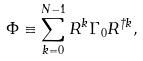<formula> <loc_0><loc_0><loc_500><loc_500>\Phi \equiv \sum _ { k = 0 } ^ { N - 1 } R ^ { k } \Gamma _ { 0 } R ^ { \dagger k } ,</formula> 